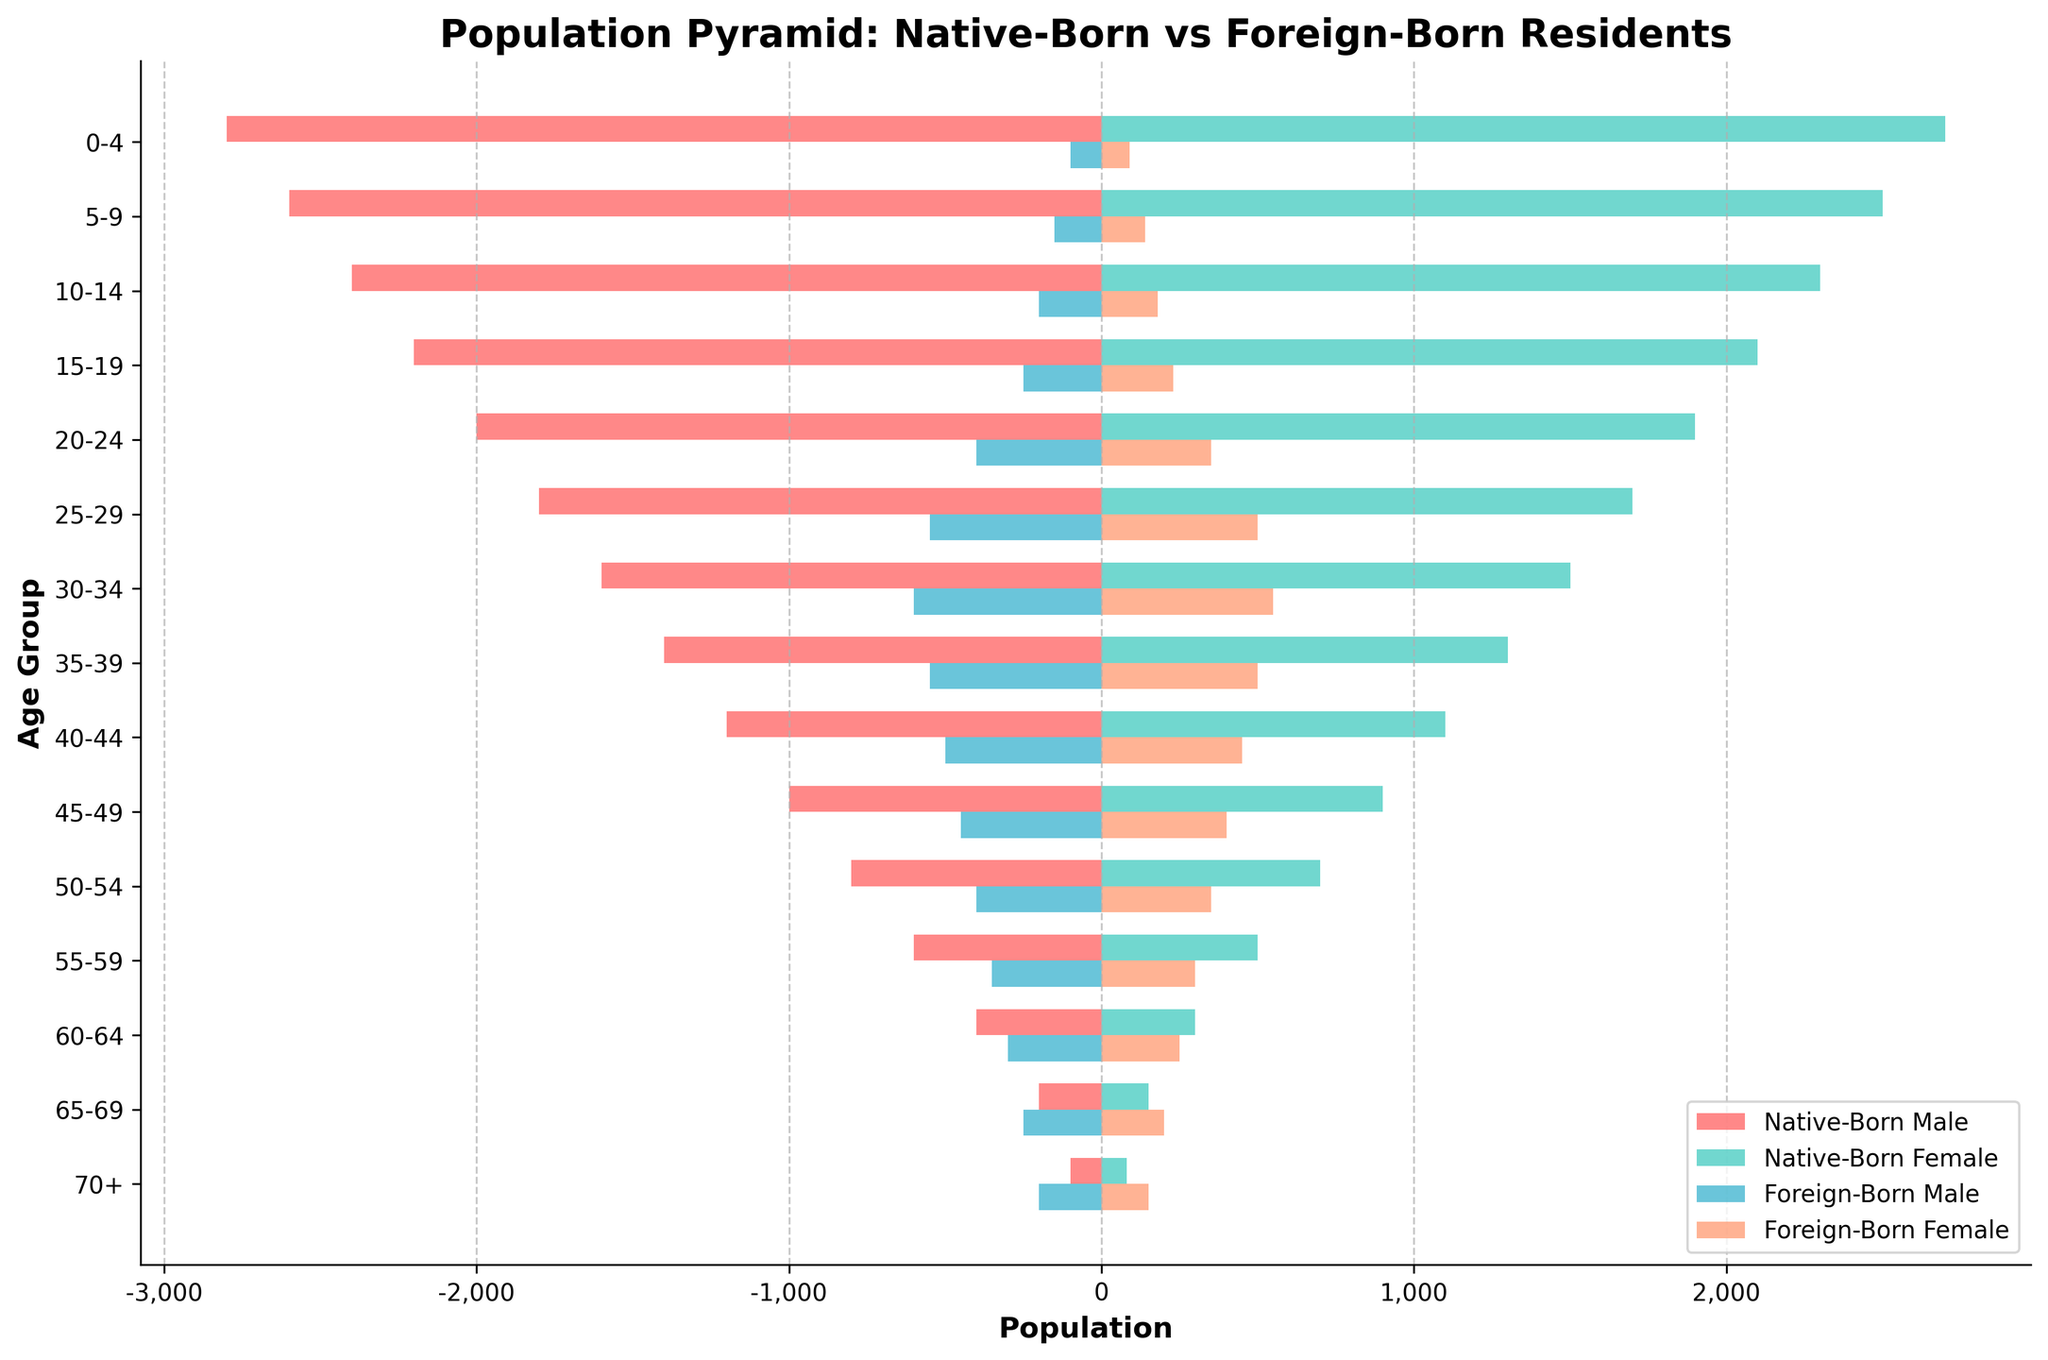What's the total population of native-born residents aged 25-29? To find the total population of native-born residents aged 25-29, add the number of native-born males and females in that age group: 1800 (male) + 1700 (female) = 3500.
Answer: 3500 What is the difference in the number of foreign-born males aged 30-34 compared to native-born males in the same age group? To find the difference, subtract the number of foreign-born males aged 30-34 from the native-born males in that age group: 1600 (native-born male) - 600 (foreign-born male) = 1000.
Answer: 1000 Which gender and age group have the smallest foreign-born population? The smallest foreign-born population is for males aged 0-4, with a population of 100.
Answer: Males aged 0-4 How does the population of native-born people aged 40-44 compare to foreign-born people in the same age group? Calculate the total native-born population aged 40-44 by adding males and females: 1200 (male) + 1100 (female) = 2300. Calculate the total foreign-born population aged 40-44: 500 (male) + 450 (female) = 950. The native-born population is higher.
Answer: Native-born population is higher Identify the age group with the highest number of foreign-born females. The highest number of foreign-born females is in the age group 30-34, with 550.
Answer: 30-34 What's the ratio of native-born males to foreign-born males aged 20-24? Calculate the ratio by dividing the number of native-born males by foreign-born males in that age group: 2000 (native-born) / 400 (foreign-born) = 5.
Answer: 5 What is the proportion of native-born females aged 70+ compared to the total number of native-born residents in that age group? Find the total number of native-born residents aged 70+: 100 (male) + 80 (female) = 180. The proportion of females is 80/180 = 0.444 or 44.4%.
Answer: 44.4% Which age group has a larger gap between native-born males and females, 15-19 or 50-54? Calculate the difference for each age group: For 15-19: 2200 (males) - 2100 (females) = 100. For 50-54: 800 (males) - 700 (females) = 100. Both age groups have the same gap.
Answer: Both age groups What is the total population of foreign-born residents aged 55-59? Add the number of foreign-born males and females in that age group: 350 (male) + 300 (female) = 650.
Answer: 650 How does the number of native-born males aged 0-4 compare to the number of native-born males aged 55-59? Calculate the number of native-born males in both age groups: 2800 (age 0-4) and 600 (age 55-59). The number of native-born males aged 0-4 is larger.
Answer: Native-born males aged 0-4 are larger 